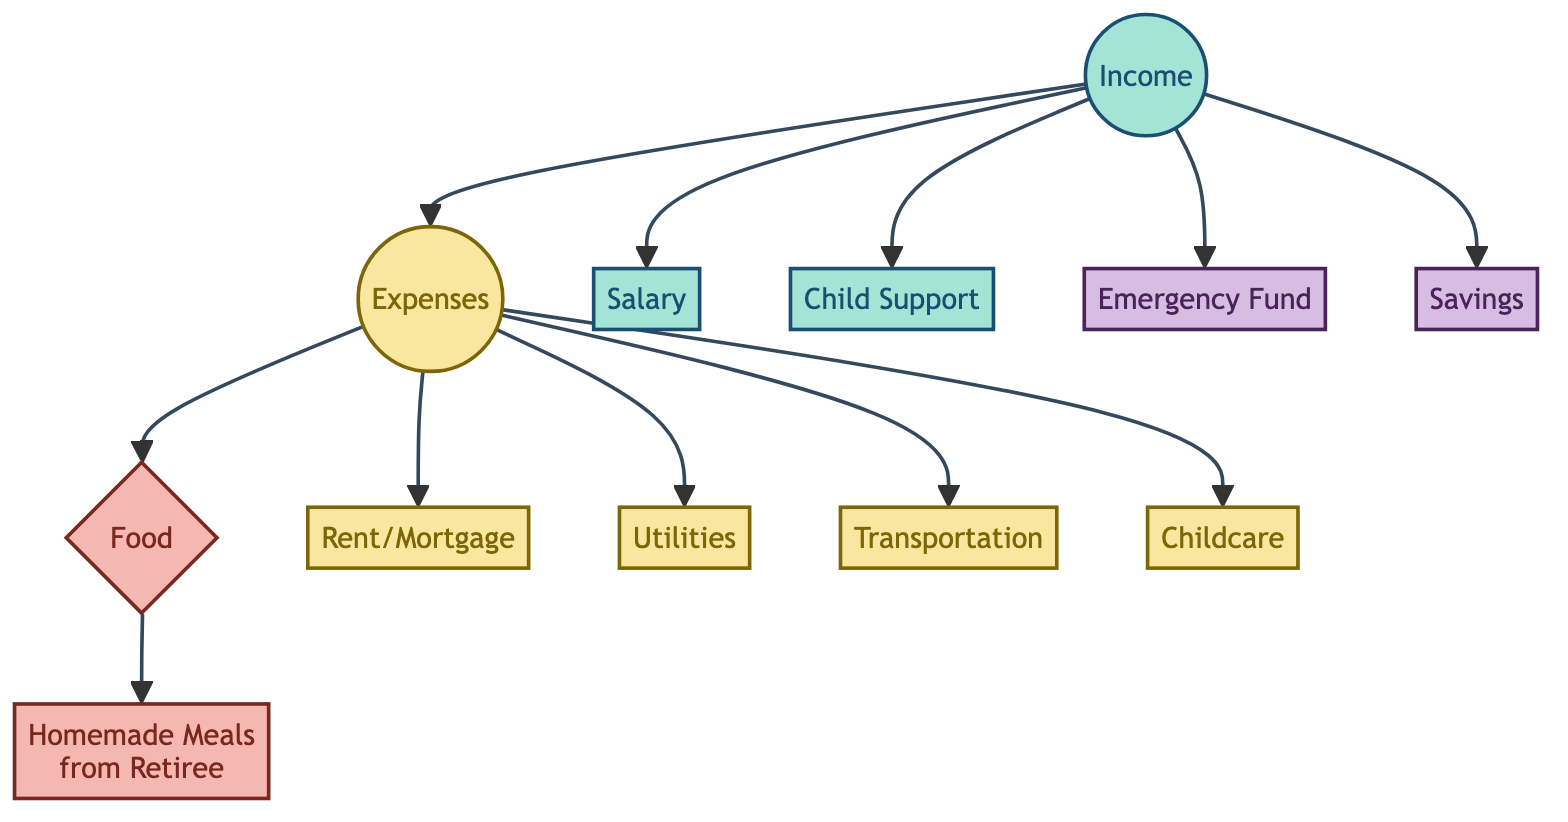How many nodes are present in the diagram? There are 12 nodes represented in the directed graph. Each node corresponds to a specific aspect of resource allocation in the budget, including income, expenses, specific categories of expenses, and savings.
Answer: 12 What is connected to "Food" in the diagram? The "Food" node has one outgoing edge that connects it to "Homemade Meals from Retiree." This indicates that food expenses have a specific source in this budget scenario.
Answer: Homemade Meals from Retiree How many types of expenses are indicated in the diagram? The expenses are distributed among several types such as Food, Rent/Mortgage, Utilities, Transportation, and Childcare – totaling five specific categories of expenses.
Answer: 5 What is the relationship between "Income" and "Expenses"? The directed edge from "Income" to "Expenses" signifies that income is a prerequisite or source of funds that ultimately leads to the categorization of expenses.
Answer: Source Which node has the most incoming edges? The "Expenses" node has multiple incoming edges from "Income," indicating that it is directly fed by different income sources, making it the hub for outgoing expenses in the budget.
Answer: Expenses What is the primary purpose of the "Emergency Fund" node in the diagram? The "Emergency Fund" node indicates a portion of income that is set aside for unexpected expenses, showcasing a component of savings within the overall resource allocation strategy.
Answer: Savings How does "Salary" contribute to overall "Income"? "Salary" is one of the sources contributing to the "Income" node, indicating that it is a significant component of the financial resources available for expenses and savings.
Answer: Contributes What are the types of supports included in "Income"? The "Income" node encompasses two categories: "Salary" and "Child Support," showcasing different forms of income that provide financial resources.
Answer: Salary, Child Support What is a key outcome of the "Food" expenses? The key outcome from the "Food" expenses is "Homemade Meals from Retiree," which shows a direct relationship where a part of the food budget translates into meals provided by a retiree.
Answer: Homemade Meals from Retiree 